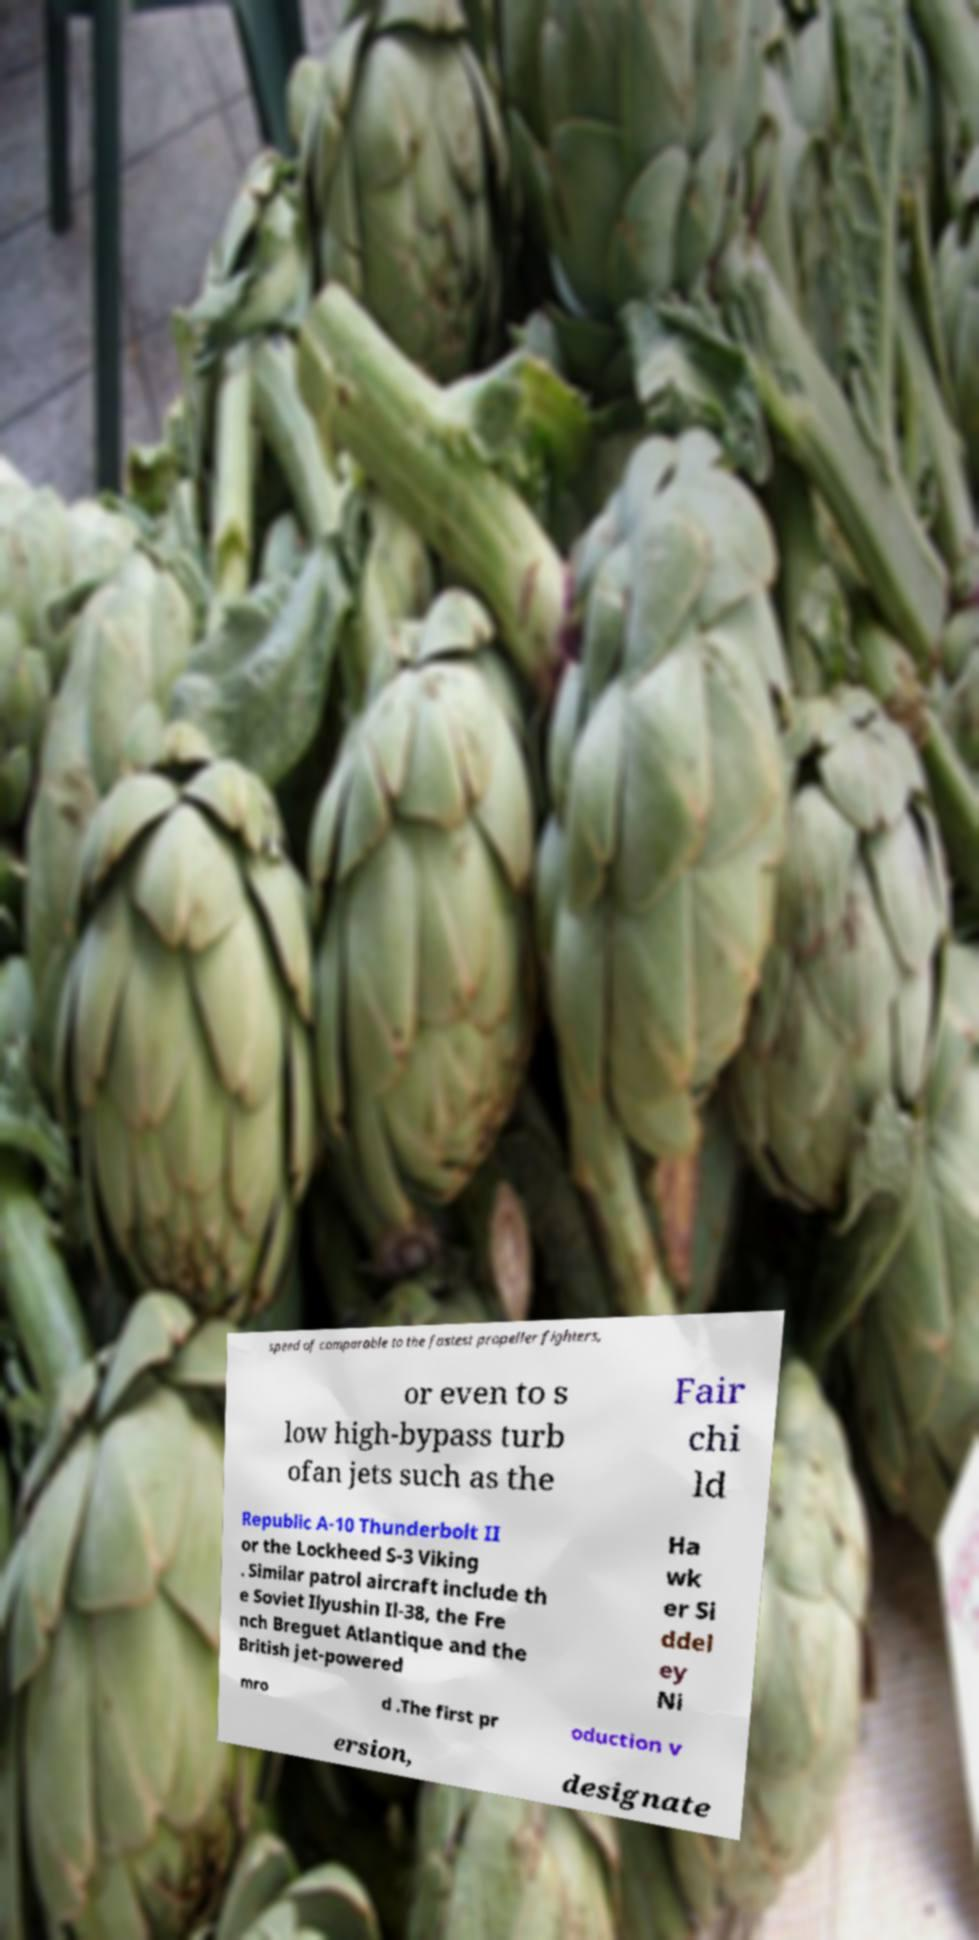Can you read and provide the text displayed in the image?This photo seems to have some interesting text. Can you extract and type it out for me? speed of comparable to the fastest propeller fighters, or even to s low high-bypass turb ofan jets such as the Fair chi ld Republic A-10 Thunderbolt II or the Lockheed S-3 Viking . Similar patrol aircraft include th e Soviet Ilyushin Il-38, the Fre nch Breguet Atlantique and the British jet-powered Ha wk er Si ddel ey Ni mro d .The first pr oduction v ersion, designate 